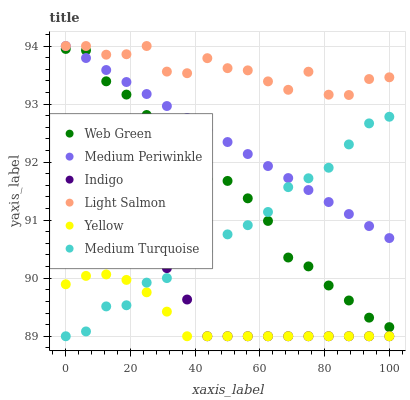Does Yellow have the minimum area under the curve?
Answer yes or no. Yes. Does Light Salmon have the maximum area under the curve?
Answer yes or no. Yes. Does Indigo have the minimum area under the curve?
Answer yes or no. No. Does Indigo have the maximum area under the curve?
Answer yes or no. No. Is Medium Periwinkle the smoothest?
Answer yes or no. Yes. Is Light Salmon the roughest?
Answer yes or no. Yes. Is Indigo the smoothest?
Answer yes or no. No. Is Indigo the roughest?
Answer yes or no. No. Does Indigo have the lowest value?
Answer yes or no. Yes. Does Medium Periwinkle have the lowest value?
Answer yes or no. No. Does Medium Periwinkle have the highest value?
Answer yes or no. Yes. Does Indigo have the highest value?
Answer yes or no. No. Is Indigo less than Web Green?
Answer yes or no. Yes. Is Medium Periwinkle greater than Yellow?
Answer yes or no. Yes. Does Yellow intersect Indigo?
Answer yes or no. Yes. Is Yellow less than Indigo?
Answer yes or no. No. Is Yellow greater than Indigo?
Answer yes or no. No. Does Indigo intersect Web Green?
Answer yes or no. No. 